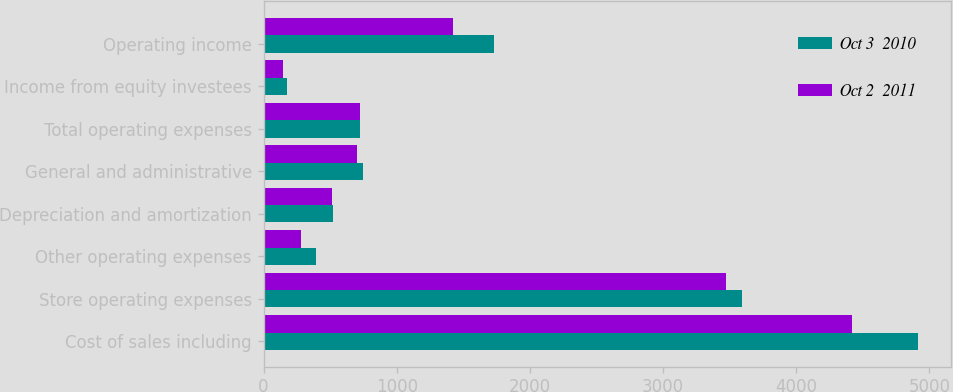Convert chart to OTSL. <chart><loc_0><loc_0><loc_500><loc_500><stacked_bar_chart><ecel><fcel>Cost of sales including<fcel>Store operating expenses<fcel>Other operating expenses<fcel>Depreciation and amortization<fcel>General and administrative<fcel>Total operating expenses<fcel>Income from equity investees<fcel>Operating income<nl><fcel>Oct 3  2010<fcel>4915.5<fcel>3594.9<fcel>392.8<fcel>523.3<fcel>749.3<fcel>726.95<fcel>173.7<fcel>1728.5<nl><fcel>Oct 2  2011<fcel>4416.5<fcel>3471.9<fcel>279.7<fcel>510.4<fcel>704.6<fcel>726.95<fcel>148.1<fcel>1419.4<nl></chart> 